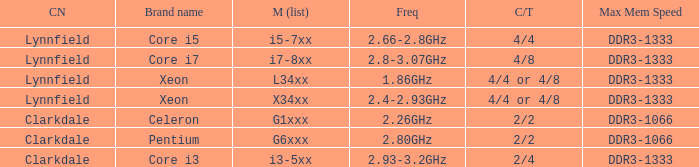What brand is model I7-8xx? Core i7. 